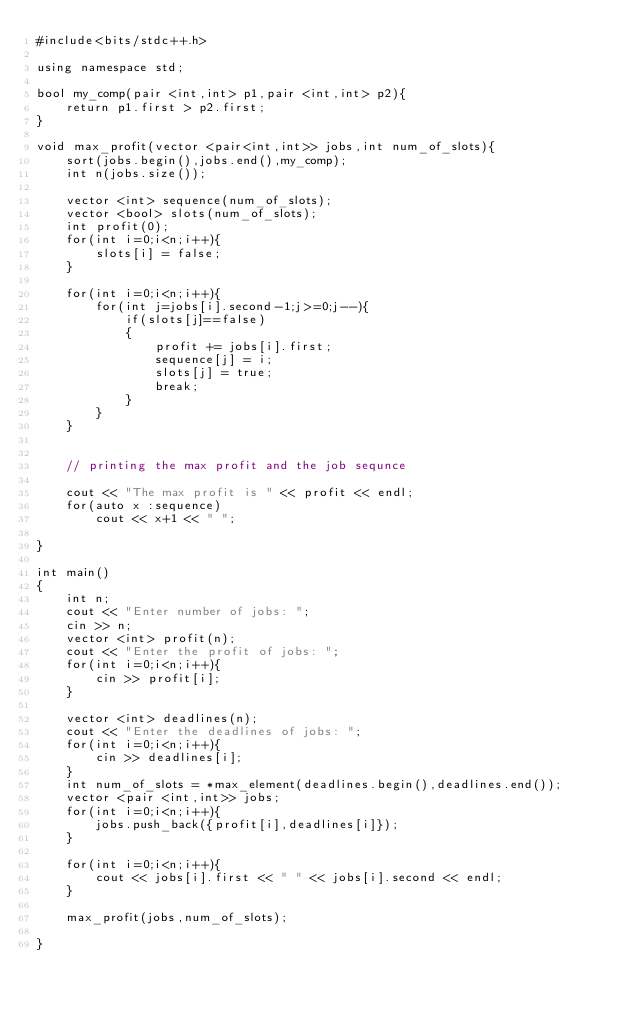<code> <loc_0><loc_0><loc_500><loc_500><_C++_>#include<bits/stdc++.h>

using namespace std;

bool my_comp(pair <int,int> p1,pair <int,int> p2){
    return p1.first > p2.first;
}

void max_profit(vector <pair<int,int>> jobs,int num_of_slots){
    sort(jobs.begin(),jobs.end(),my_comp);
    int n(jobs.size());

    vector <int> sequence(num_of_slots);
    vector <bool> slots(num_of_slots);
    int profit(0);
    for(int i=0;i<n;i++){
        slots[i] = false;
    }

    for(int i=0;i<n;i++){
        for(int j=jobs[i].second-1;j>=0;j--){
            if(slots[j]==false)
            {
                profit += jobs[i].first;
                sequence[j] = i;
                slots[j] = true;
                break;
            }
        }
    }
    

    // printing the max profit and the job sequnce 

    cout << "The max profit is " << profit << endl;
    for(auto x :sequence)
        cout << x+1 << " ";

}

int main()
{
    int n;
    cout << "Enter number of jobs: ";
    cin >> n;
    vector <int> profit(n);
    cout << "Enter the profit of jobs: ";
    for(int i=0;i<n;i++){
        cin >> profit[i];
    }

    vector <int> deadlines(n);
    cout << "Enter the deadlines of jobs: ";
    for(int i=0;i<n;i++){
        cin >> deadlines[i];
    }
    int num_of_slots = *max_element(deadlines.begin(),deadlines.end());
    vector <pair <int,int>> jobs;
    for(int i=0;i<n;i++){
        jobs.push_back({profit[i],deadlines[i]});
    }

    for(int i=0;i<n;i++){
        cout << jobs[i].first << " " << jobs[i].second << endl; 
    }

    max_profit(jobs,num_of_slots);

}</code> 